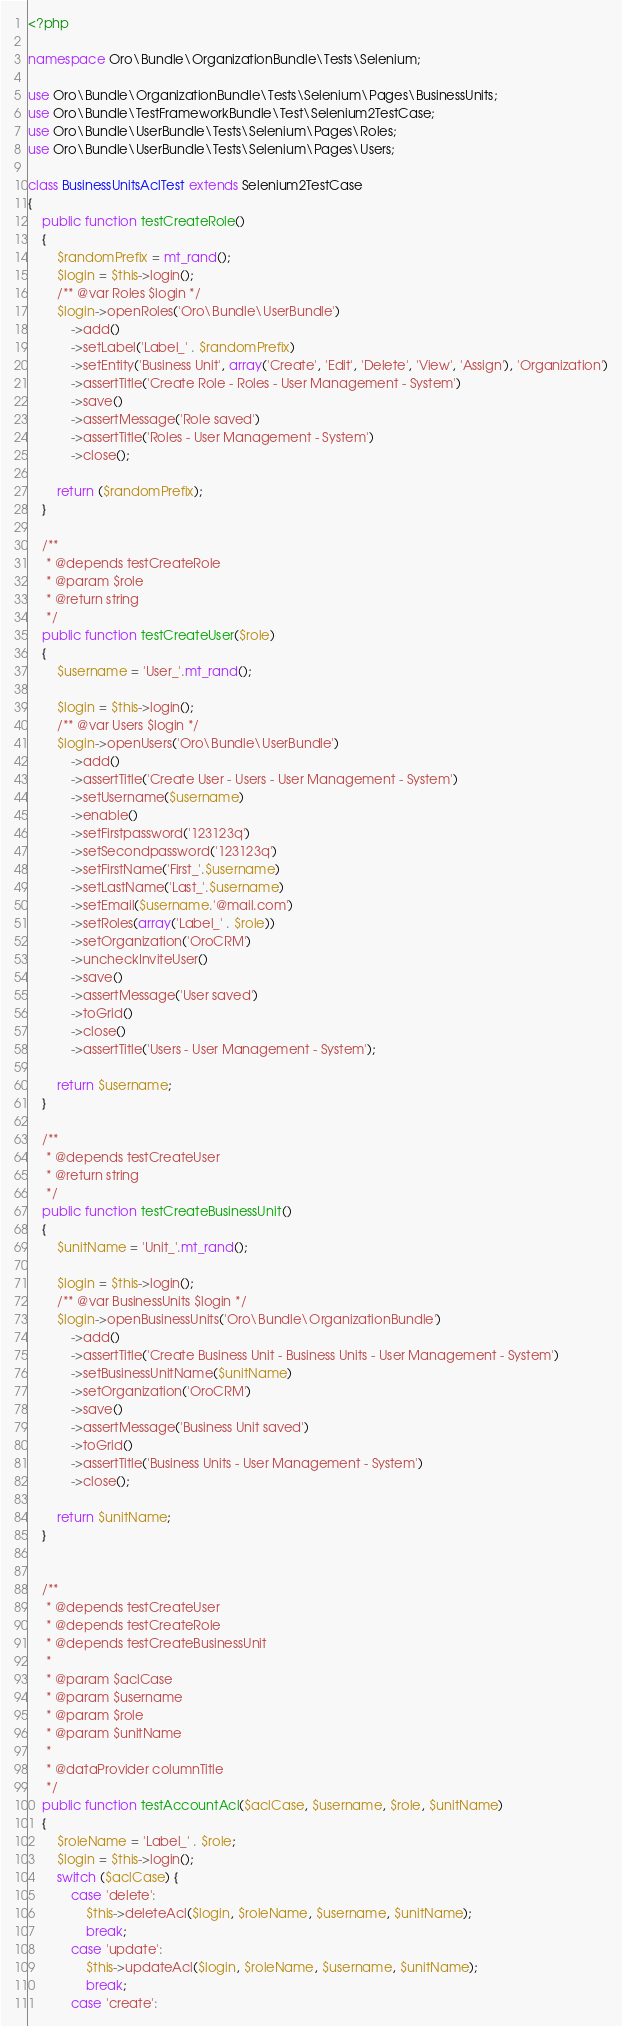<code> <loc_0><loc_0><loc_500><loc_500><_PHP_><?php

namespace Oro\Bundle\OrganizationBundle\Tests\Selenium;

use Oro\Bundle\OrganizationBundle\Tests\Selenium\Pages\BusinessUnits;
use Oro\Bundle\TestFrameworkBundle\Test\Selenium2TestCase;
use Oro\Bundle\UserBundle\Tests\Selenium\Pages\Roles;
use Oro\Bundle\UserBundle\Tests\Selenium\Pages\Users;

class BusinessUnitsAclTest extends Selenium2TestCase
{
    public function testCreateRole()
    {
        $randomPrefix = mt_rand();
        $login = $this->login();
        /** @var Roles $login */
        $login->openRoles('Oro\Bundle\UserBundle')
            ->add()
            ->setLabel('Label_' . $randomPrefix)
            ->setEntity('Business Unit', array('Create', 'Edit', 'Delete', 'View', 'Assign'), 'Organization')
            ->assertTitle('Create Role - Roles - User Management - System')
            ->save()
            ->assertMessage('Role saved')
            ->assertTitle('Roles - User Management - System')
            ->close();

        return ($randomPrefix);
    }

    /**
     * @depends testCreateRole
     * @param $role
     * @return string
     */
    public function testCreateUser($role)
    {
        $username = 'User_'.mt_rand();

        $login = $this->login();
        /** @var Users $login */
        $login->openUsers('Oro\Bundle\UserBundle')
            ->add()
            ->assertTitle('Create User - Users - User Management - System')
            ->setUsername($username)
            ->enable()
            ->setFirstpassword('123123q')
            ->setSecondpassword('123123q')
            ->setFirstName('First_'.$username)
            ->setLastName('Last_'.$username)
            ->setEmail($username.'@mail.com')
            ->setRoles(array('Label_' . $role))
            ->setOrganization('OroCRM')
            ->uncheckInviteUser()
            ->save()
            ->assertMessage('User saved')
            ->toGrid()
            ->close()
            ->assertTitle('Users - User Management - System');

        return $username;
    }

    /**
     * @depends testCreateUser
     * @return string
     */
    public function testCreateBusinessUnit()
    {
        $unitName = 'Unit_'.mt_rand();

        $login = $this->login();
        /** @var BusinessUnits $login */
        $login->openBusinessUnits('Oro\Bundle\OrganizationBundle')
            ->add()
            ->assertTitle('Create Business Unit - Business Units - User Management - System')
            ->setBusinessUnitName($unitName)
            ->setOrganization('OroCRM')
            ->save()
            ->assertMessage('Business Unit saved')
            ->toGrid()
            ->assertTitle('Business Units - User Management - System')
            ->close();

        return $unitName;
    }


    /**
     * @depends testCreateUser
     * @depends testCreateRole
     * @depends testCreateBusinessUnit
     *
     * @param $aclCase
     * @param $username
     * @param $role
     * @param $unitName
     *
     * @dataProvider columnTitle
     */
    public function testAccountAcl($aclCase, $username, $role, $unitName)
    {
        $roleName = 'Label_' . $role;
        $login = $this->login();
        switch ($aclCase) {
            case 'delete':
                $this->deleteAcl($login, $roleName, $username, $unitName);
                break;
            case 'update':
                $this->updateAcl($login, $roleName, $username, $unitName);
                break;
            case 'create':</code> 